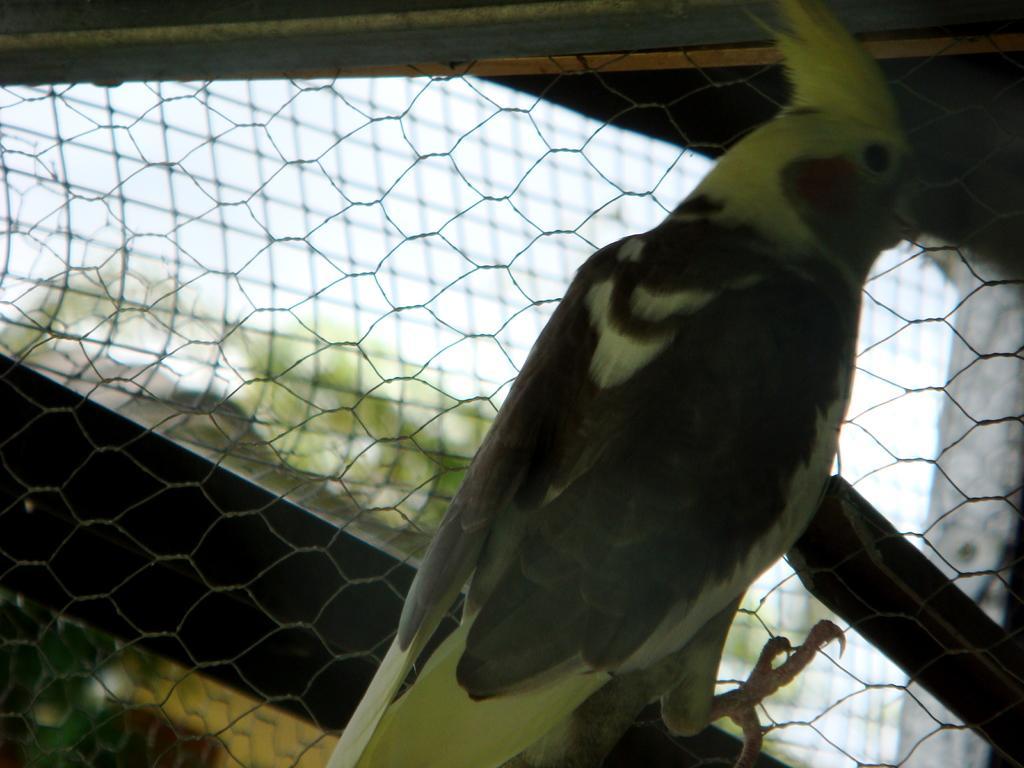In one or two sentences, can you explain what this image depicts? In this image I can see the bird which is in black and green color. It is on the net. In the back I can see the trees and the sky. 